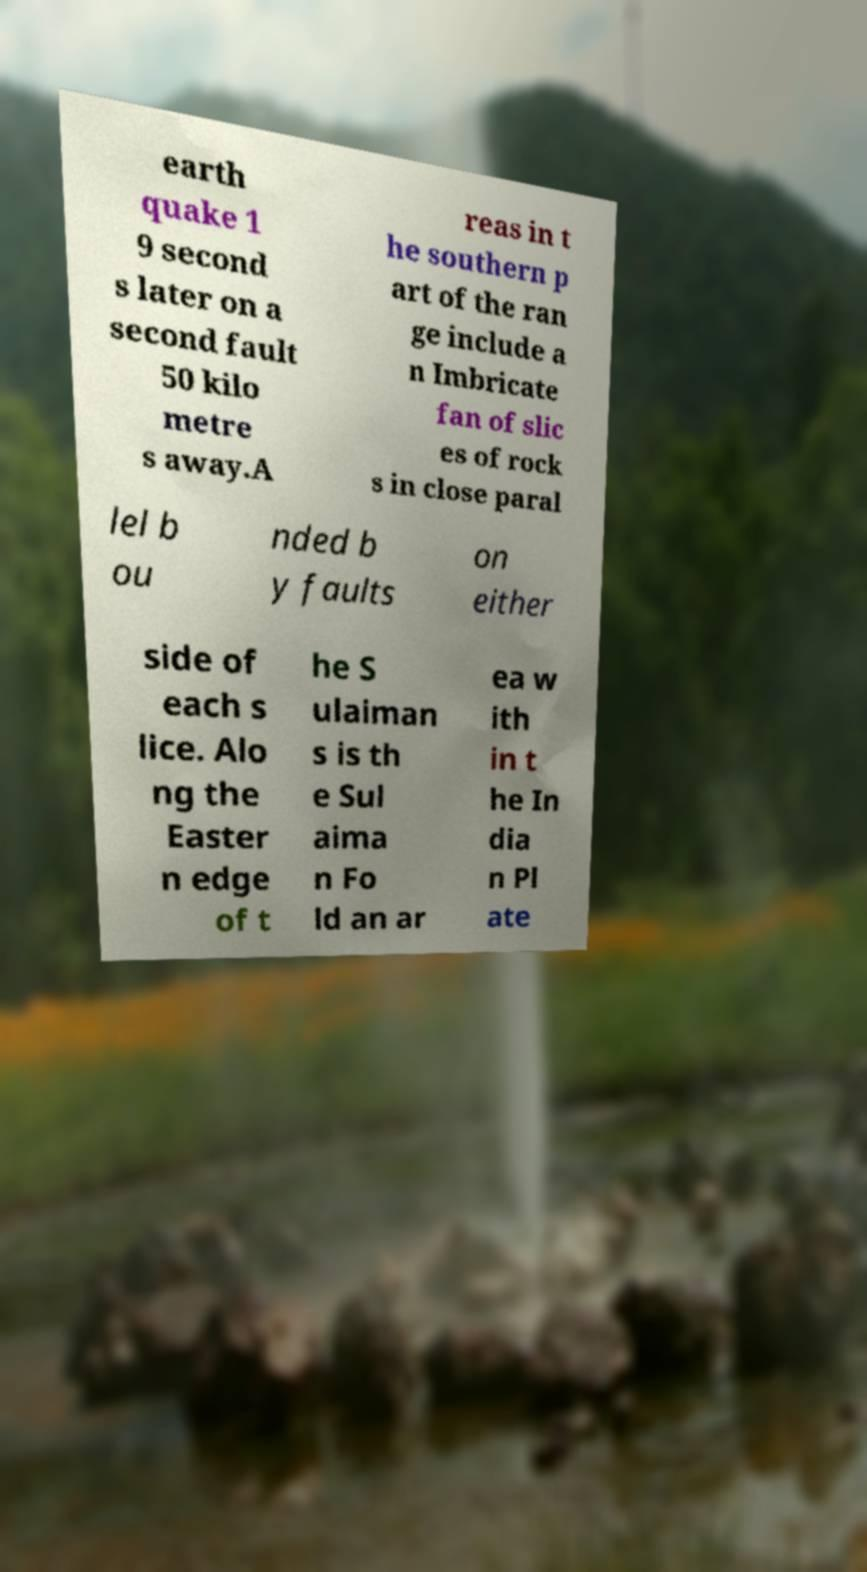Could you extract and type out the text from this image? earth quake 1 9 second s later on a second fault 50 kilo metre s away.A reas in t he southern p art of the ran ge include a n Imbricate fan of slic es of rock s in close paral lel b ou nded b y faults on either side of each s lice. Alo ng the Easter n edge of t he S ulaiman s is th e Sul aima n Fo ld an ar ea w ith in t he In dia n Pl ate 